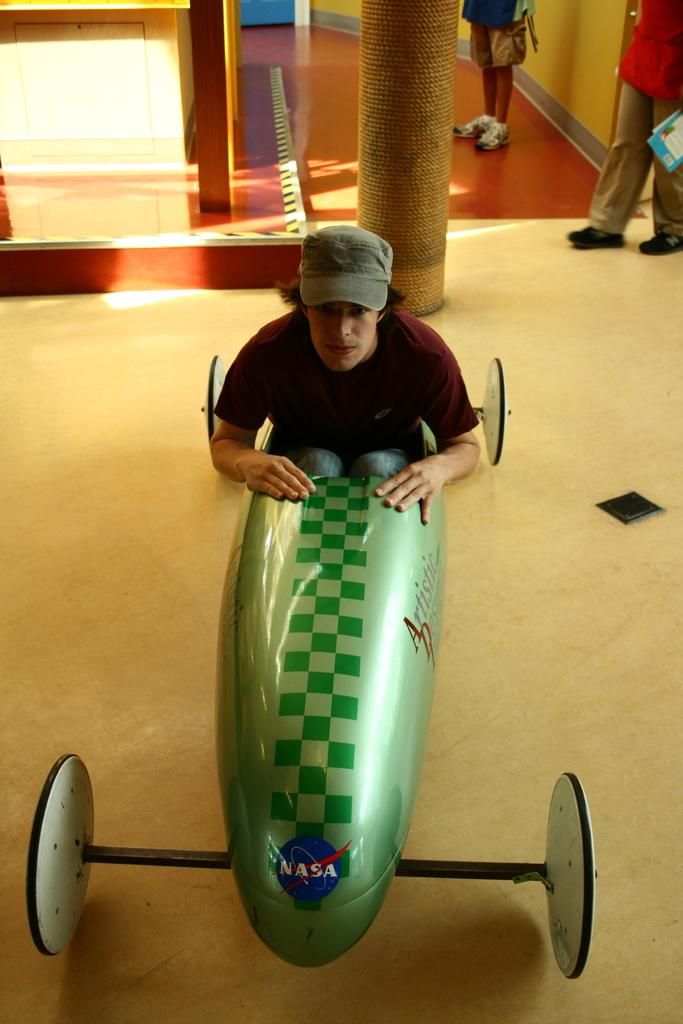<image>
Provide a brief description of the given image. a man in a soap box with a Nasa sticker on it 